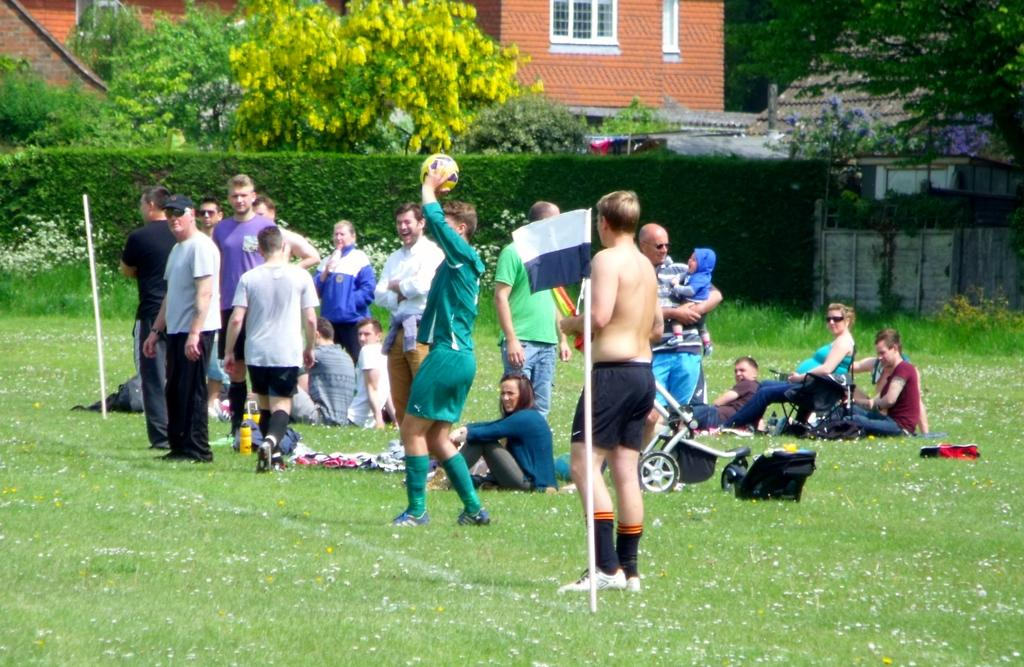What are the people in the image doing? The people in the image are standing and sitting on the grass land. What object is one person holding? One person is holding a volleyball. What structure is visible behind the people? There is a building behind the people. What type of vegetation can be seen behind the building? Trees are visible behind the building. What type of pear is being used as a zinc roofing material in the image? There is no pear or zinc roofing material present in the image. 